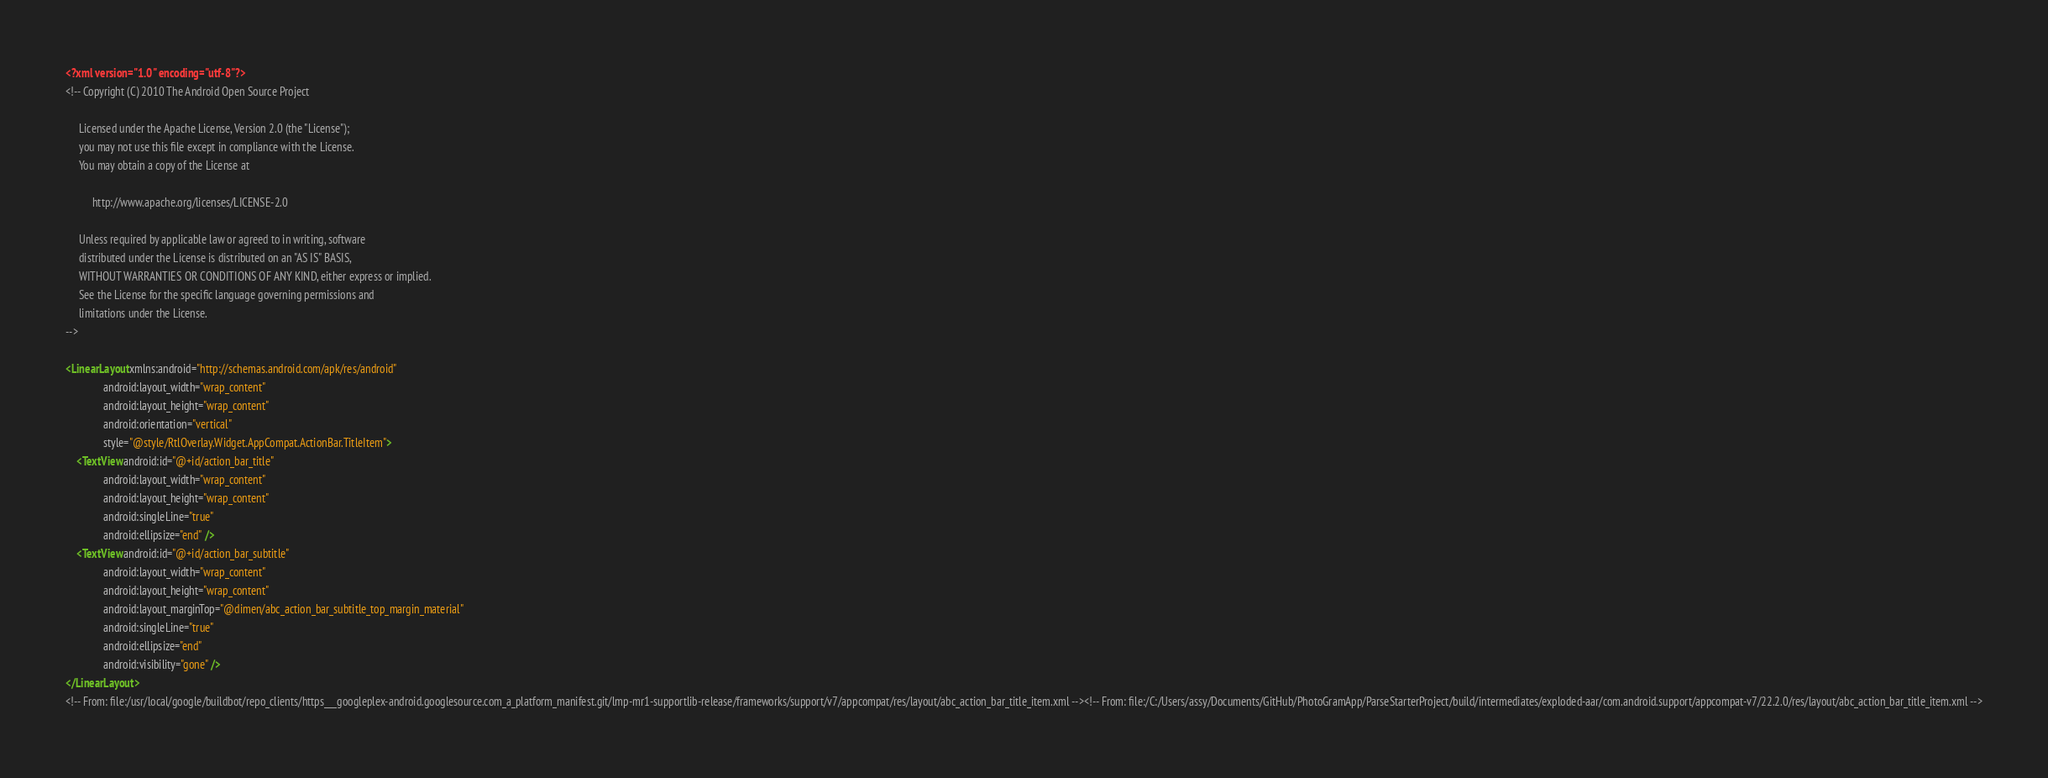<code> <loc_0><loc_0><loc_500><loc_500><_XML_><?xml version="1.0" encoding="utf-8"?>
<!-- Copyright (C) 2010 The Android Open Source Project

     Licensed under the Apache License, Version 2.0 (the "License");
     you may not use this file except in compliance with the License.
     You may obtain a copy of the License at
  
          http://www.apache.org/licenses/LICENSE-2.0
  
     Unless required by applicable law or agreed to in writing, software
     distributed under the License is distributed on an "AS IS" BASIS,
     WITHOUT WARRANTIES OR CONDITIONS OF ANY KIND, either express or implied.
     See the License for the specific language governing permissions and
     limitations under the License.
-->

<LinearLayout xmlns:android="http://schemas.android.com/apk/res/android"
              android:layout_width="wrap_content"
              android:layout_height="wrap_content"
              android:orientation="vertical"
              style="@style/RtlOverlay.Widget.AppCompat.ActionBar.TitleItem">
    <TextView android:id="@+id/action_bar_title"
              android:layout_width="wrap_content"
              android:layout_height="wrap_content"
              android:singleLine="true"
              android:ellipsize="end" />
    <TextView android:id="@+id/action_bar_subtitle"
              android:layout_width="wrap_content"
              android:layout_height="wrap_content"
              android:layout_marginTop="@dimen/abc_action_bar_subtitle_top_margin_material"
              android:singleLine="true"
              android:ellipsize="end"
              android:visibility="gone" />
</LinearLayout>
<!-- From: file:/usr/local/google/buildbot/repo_clients/https___googleplex-android.googlesource.com_a_platform_manifest.git/lmp-mr1-supportlib-release/frameworks/support/v7/appcompat/res/layout/abc_action_bar_title_item.xml --><!-- From: file:/C:/Users/assy/Documents/GitHub/PhotoGramApp/ParseStarterProject/build/intermediates/exploded-aar/com.android.support/appcompat-v7/22.2.0/res/layout/abc_action_bar_title_item.xml --></code> 